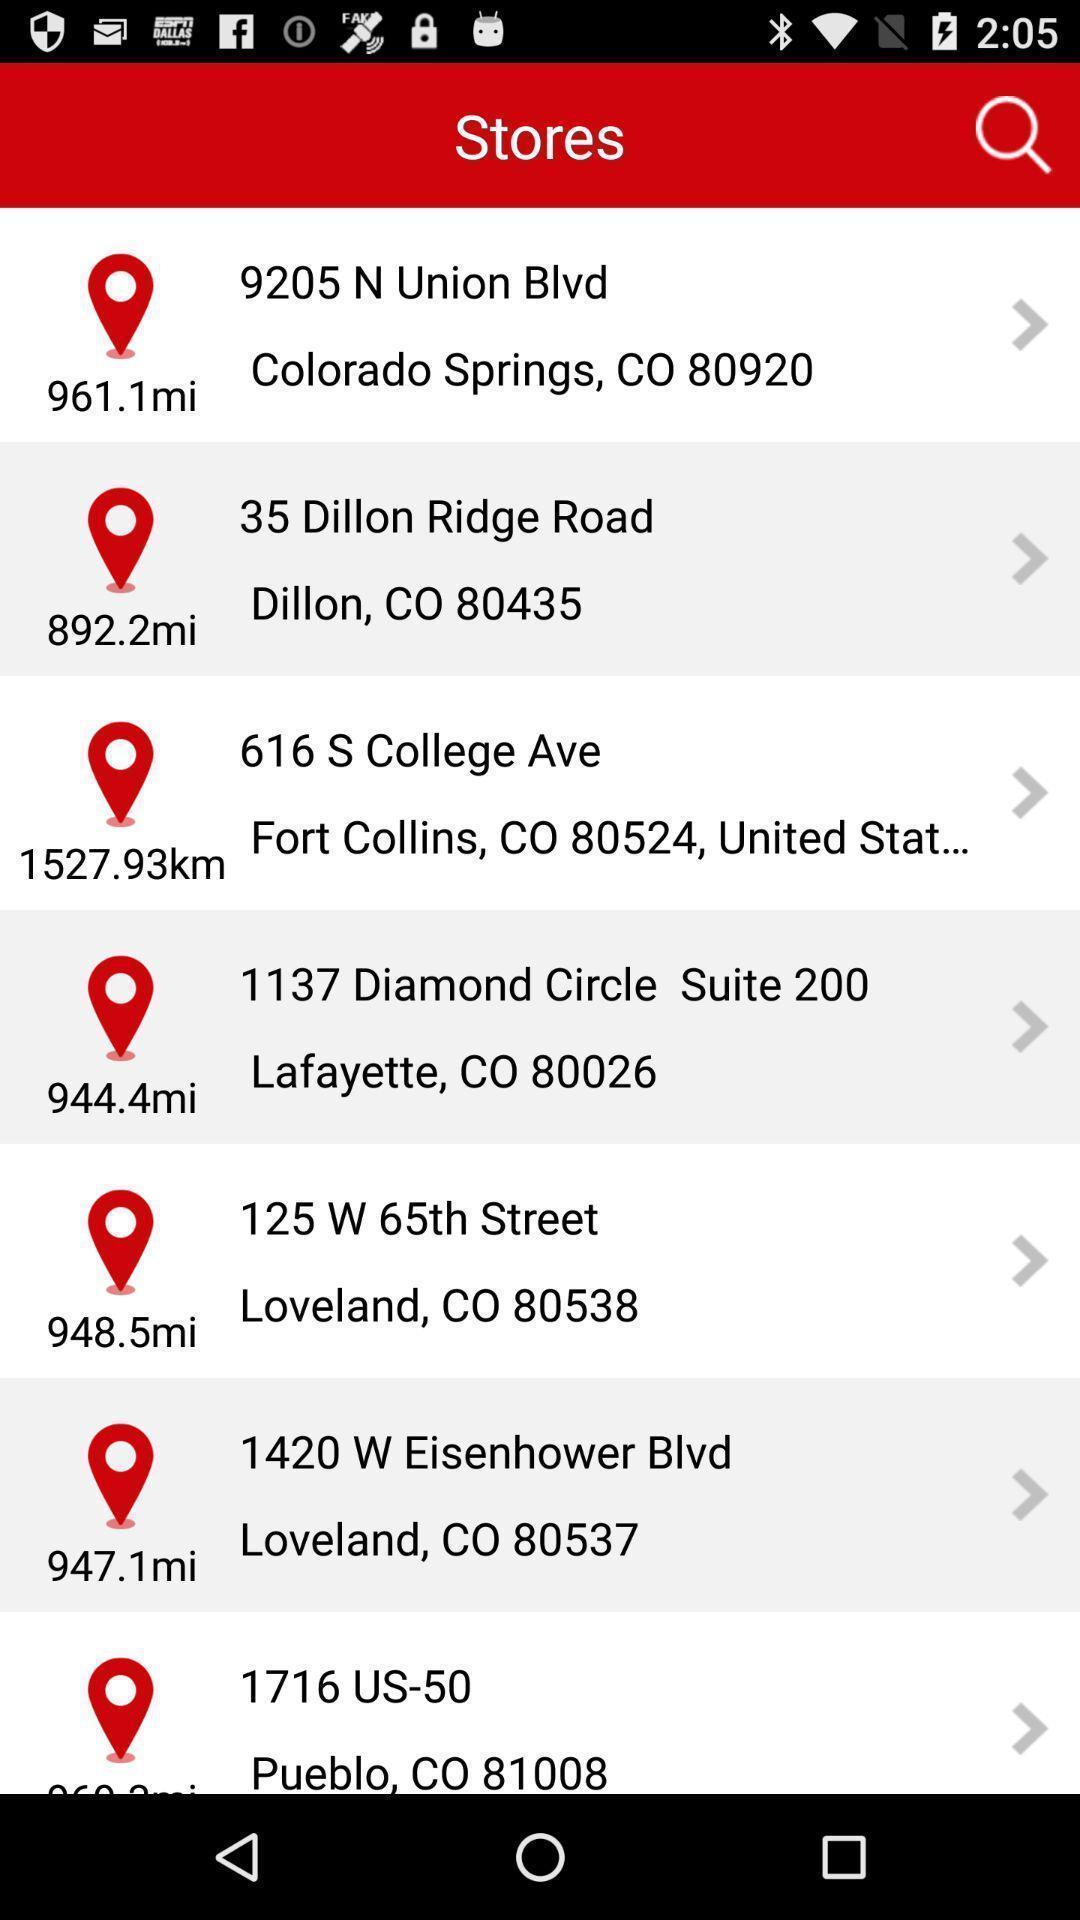What details can you identify in this image? Screen showing several stores nearby. 